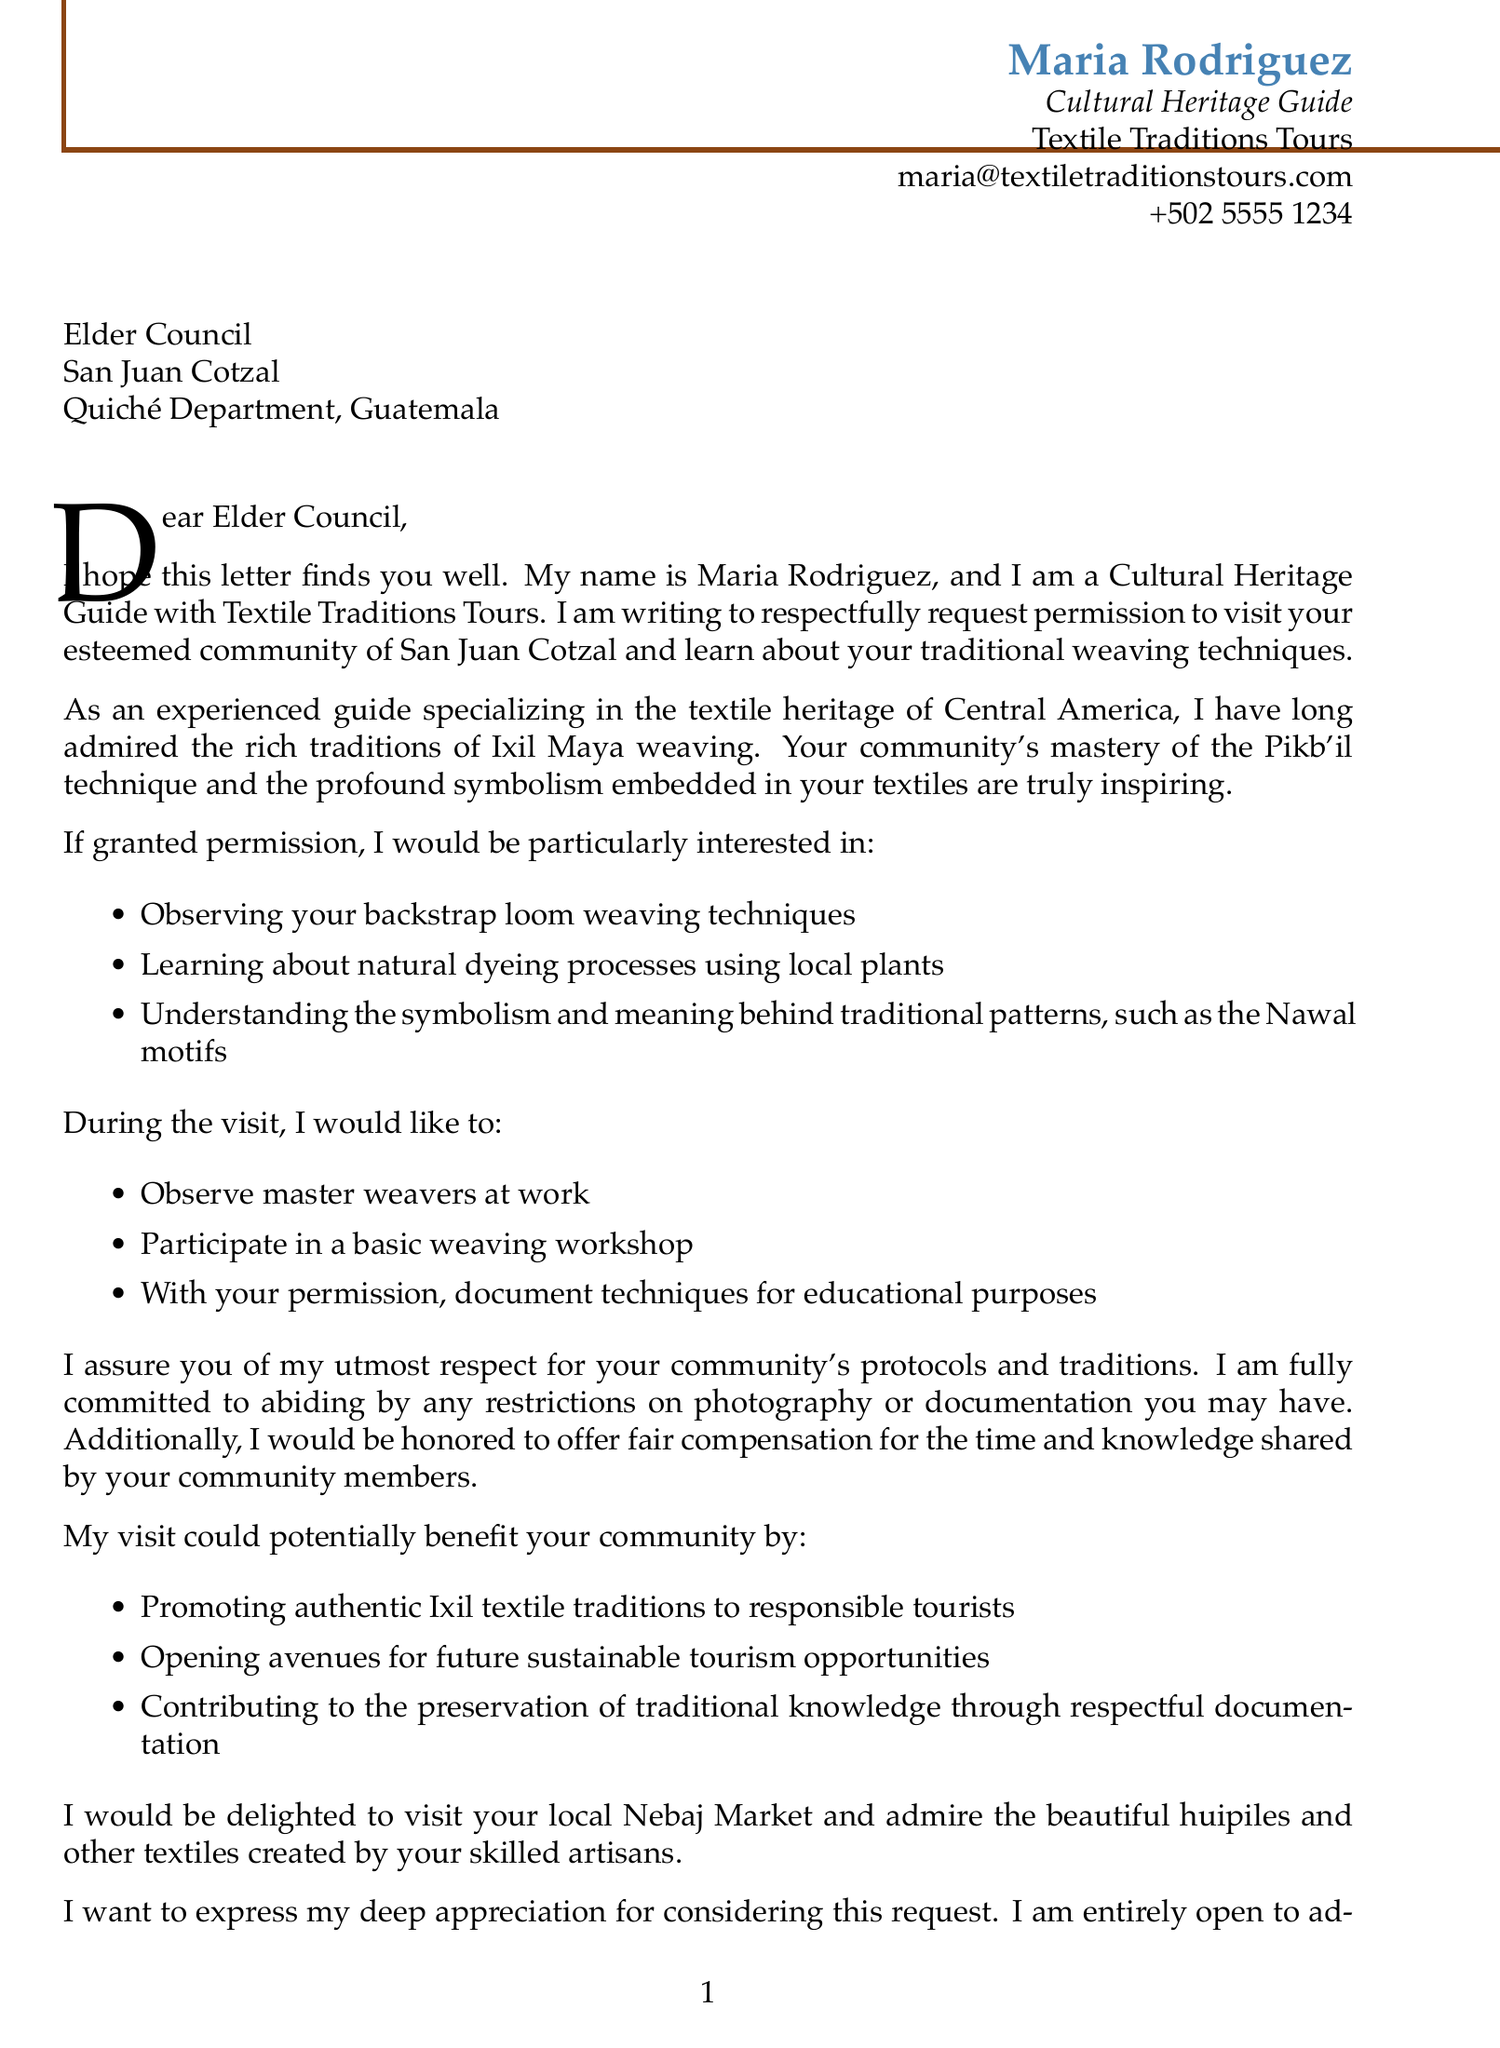What is the sender's name? The sender's name is found at the top of the letter under the sender's info section.
Answer: Maria Rodriguez What is the title of the sender? The sender's title is mentioned after the name in the sender's info section.
Answer: Cultural Heritage Guide What community is being addressed in the letter? The community is specified in the recipient info section of the letter.
Answer: San Juan Cotzal What technique does the sender want to learn about? The sender outlines specific interests in the main content section, focusing on various weaving techniques.
Answer: Backstrap loom weaving techniques What is one proposed activity during the visit? The proposed activities can be found in the main content and detail what the sender hopes to do during the visit.
Answer: Observe master weavers at work What is mentioned as a benefit to the community? Benefits to the community are listed in the document's main content.
Answer: Promotion of authentic Ixil textile traditions What does the sender express towards the end of the letter? The letter closes with an expression reflecting the sender's feelings towards the recipient's considerations.
Answer: Deep appreciation for considering this request How does the sender plan to contribute to the community? The document outlines the sender's intentions of contributing to the local economy within the cultural sensitivity section.
Answer: Fair compensation for time and knowledge What is the significant local market mentioned? The letter cites a local market relevant to the community in the additional context section.
Answer: Nebaj Market 